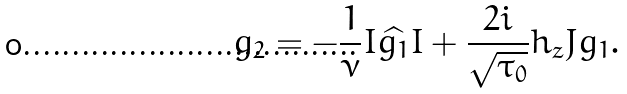<formula> <loc_0><loc_0><loc_500><loc_500>g _ { 2 } = - \frac { 1 } { \nu } I \widehat { g _ { 1 } } I + \frac { 2 i } { \sqrt { \tau _ { 0 } } } h _ { z } J g _ { 1 } .</formula> 